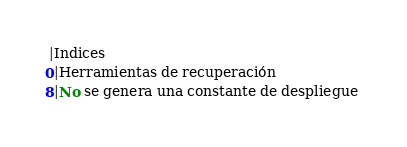<code> <loc_0><loc_0><loc_500><loc_500><_SQL_> |Indices
0|Herramientas de recuperación
8|No se genera una constante de despliegue </code> 